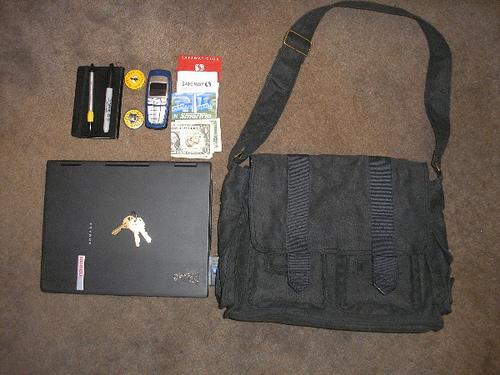Is this a Nokia mobile phone?
Write a very short answer. Yes. Would you associate the contents of this bag with a man or a woman?
Write a very short answer. Man. What brand is the laptop case?
Give a very brief answer. Nike. How many things were in the bag?
Concise answer only. 11. What denomination of money is shown?
Quick response, please. Dollar. 